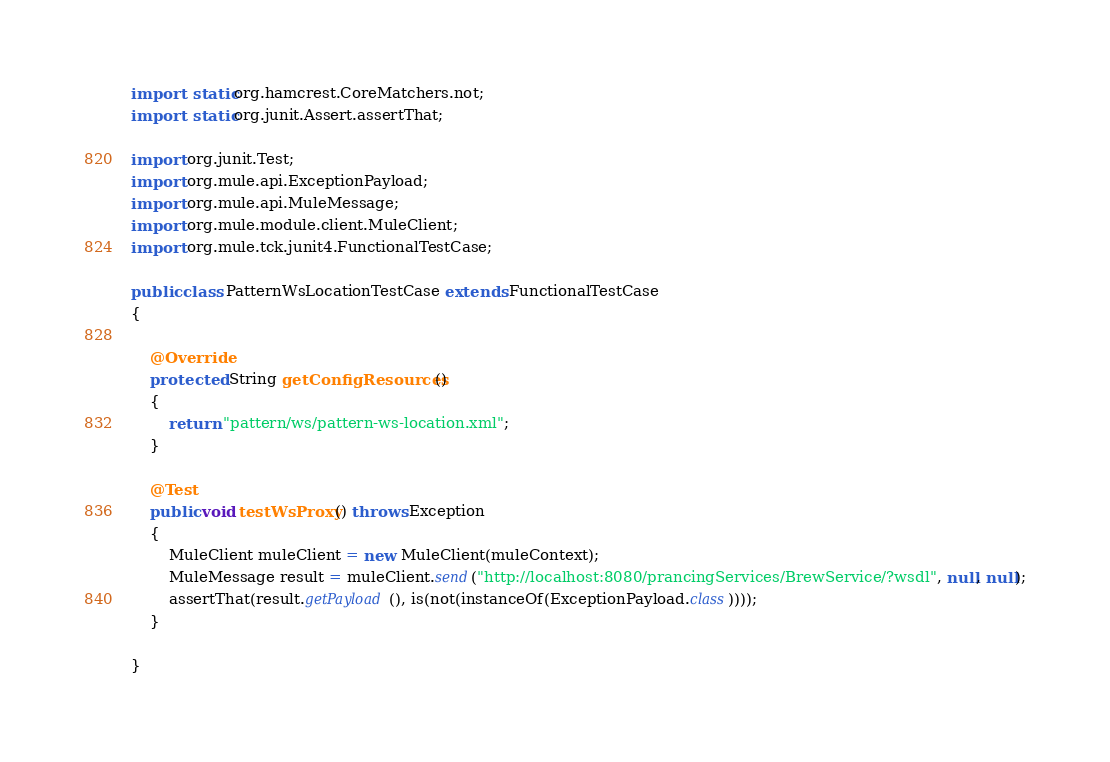Convert code to text. <code><loc_0><loc_0><loc_500><loc_500><_Java_>import static org.hamcrest.CoreMatchers.not;
import static org.junit.Assert.assertThat;

import org.junit.Test;
import org.mule.api.ExceptionPayload;
import org.mule.api.MuleMessage;
import org.mule.module.client.MuleClient;
import org.mule.tck.junit4.FunctionalTestCase;

public class PatternWsLocationTestCase extends FunctionalTestCase
{

    @Override
    protected String getConfigResources()
    {
        return "pattern/ws/pattern-ws-location.xml";
    }

    @Test
    public void testWsProxy() throws Exception
    {
        MuleClient muleClient = new MuleClient(muleContext);
        MuleMessage result = muleClient.send("http://localhost:8080/prancingServices/BrewService/?wsdl", null, null);
        assertThat(result.getPayload(), is(not(instanceOf(ExceptionPayload.class))));
    }
    
}
</code> 